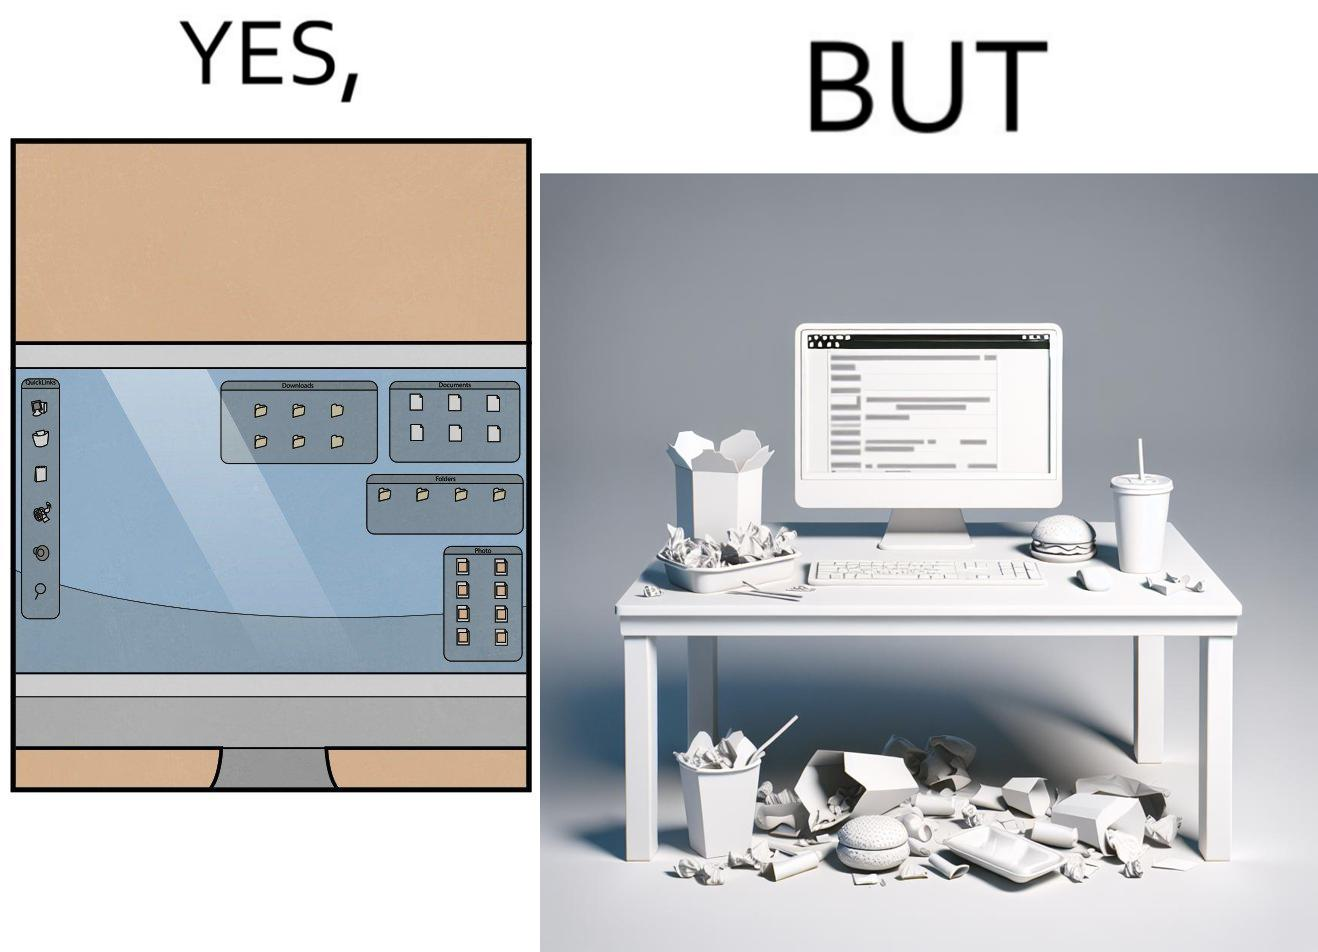What does this image depict? The image is ironical, as the folder icons on the desktop screen are very neatly arranged, while the person using the computer has littered the table with used food packets, dirty plates, and wrappers. 